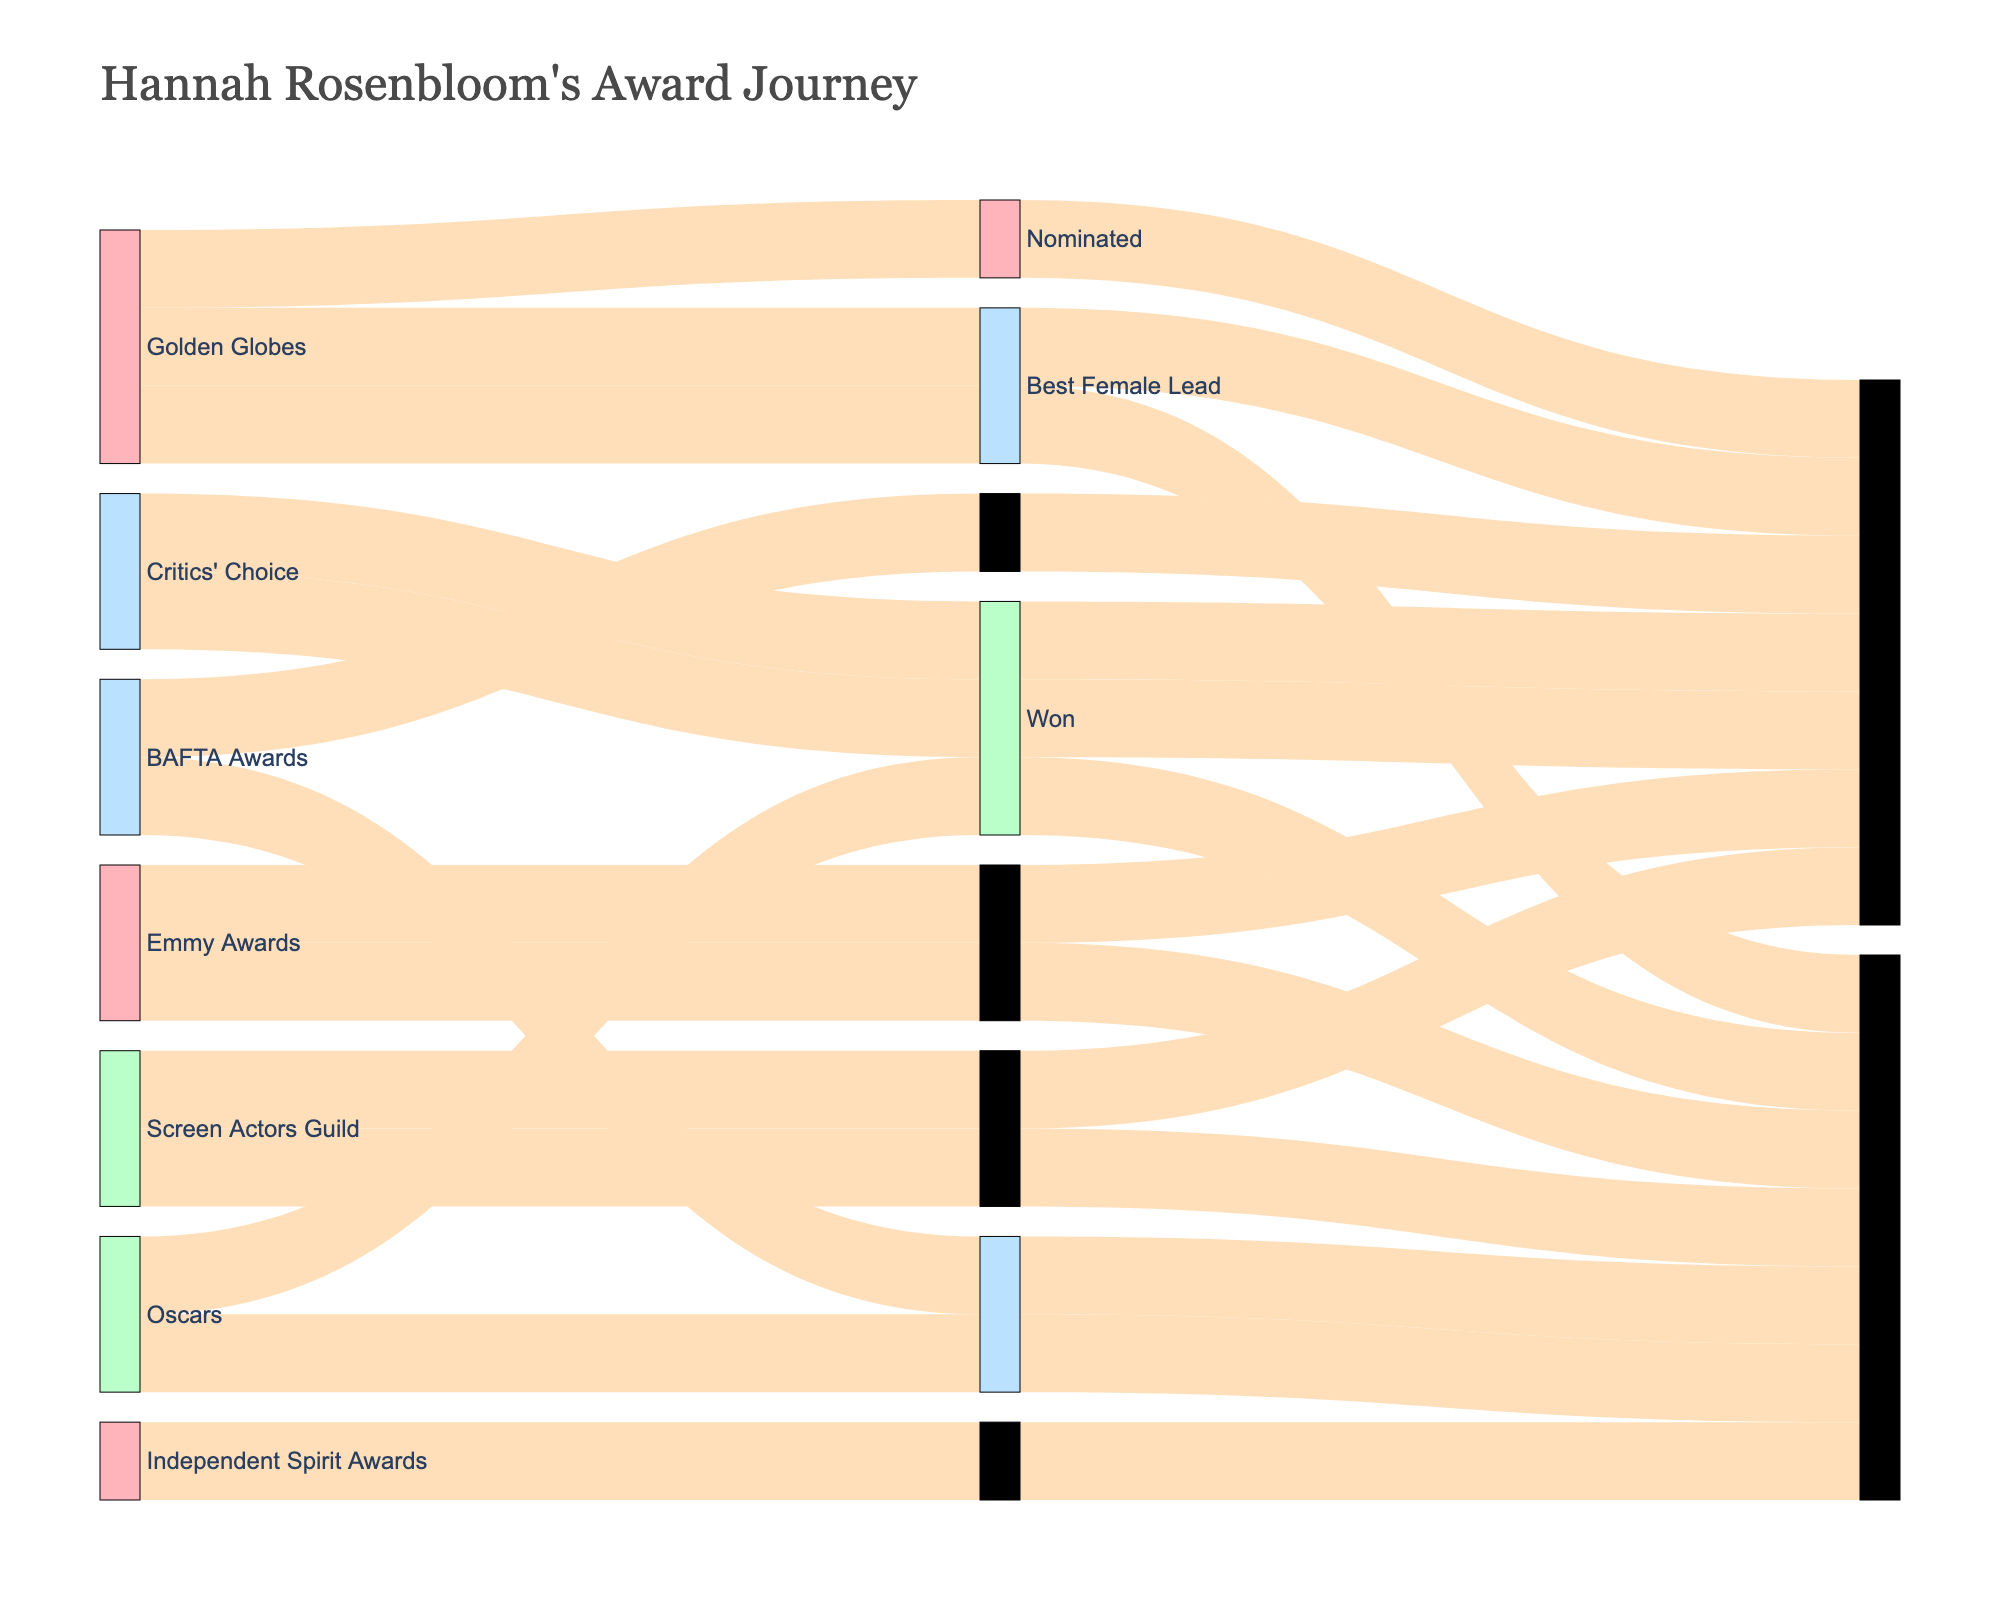who has received the most nominations, Hannah Rosenbloom or someone else? By observing the Sankey diagram, we can see the count for all nominations connected to "Nominated" for Hannah Rosenbloom across different award ceremonies, which sum up to a total. Since this is specific to Hannah's career overview, it implies she is the one with the most nominations in this context.
Answer: Hannah Rosenbloom Which award ceremony shows the highest number of nominated categories for Hannah Rosenbloom? To identify the award ceremony with the most nominated categories, we observe the Sankey diagram sections tagged as "Nominated" and trace them back to their respective sources. The "Golden Globes" ceremony has three categories connecting to "Nominated."
Answer: Golden Globes How many times has Hannah Rosenbloom been nominated for the "Best Actress" award across all ceremonies? To find the total nominations for "Best Actress" across all awards, we trace all lines flowing from nominations involving "Best Actress" to "Nominated." Counting these lines, we see there are 5 instances (3 for Golden Globes, 1 for Oscars, and 1 for Critics' Choice).
Answer: 5 Which award nomination has only resulted in wins for Hannah Rosenbloom? Looking at the links in the Sankey diagram, we would see which nomination categories are exclusively connected to the "Won" label. "Independent Spirit Awards - Best Female Lead" connects directly to "Won" without any connections to "Nominated."
Answer: Independent Spirit Awards - Best Female Lead Does Hannah Rosenbloom have more nominations or wins in the "Oscars" category? To determine this, we compare the flow lines from "Oscars" to "Nominated" and those from "Oscars" to "Won." There is 1 line leading to "Nominated" and 1 leading to "Won," indicating equal counts.
Answer: Equal counts Which nominated category has resulted in the most wins for Hannah Rosenbloom? We count how many paths lead from each nominated category to "Won." "Best Actress - Drama," "Best Supporting Actress," "Outstanding Lead Actress," "Outstanding Performance by a Female Actor," "Best Actress," and "Best Female Lead" all lead to wins, but each one has equal flows of 1 win. Therefore, multiple categories have resulted in one win each.
Answer: Multiple categories (6 total) What is the color used for the nodes representing "Nominated" statuses? By observing the color code in the Sankey diagram, "Nominated" nodes use a distinct blue-tinted color.
Answer: Blue-tinted Can you identify which award ceremony did not have a win for Hannah Rosenbloom? By tracing the flows going towards "Nominated" and looking for any absence of lines to "Won," we see that "BAFTA Awards" has a nomination but no corresponding win.
Answer: BAFTA Awards Among "Golden Globes" and "Screen Actors Guild," which one reflects more variation in the nomination types for Hannah Rosenbloom? We can compare the number of distinct nomination categories connected from each source node. "Golden Globes" has three different nominations, while "Screen Actors Guild" has only one nomination type.
Answer: Golden Globes 